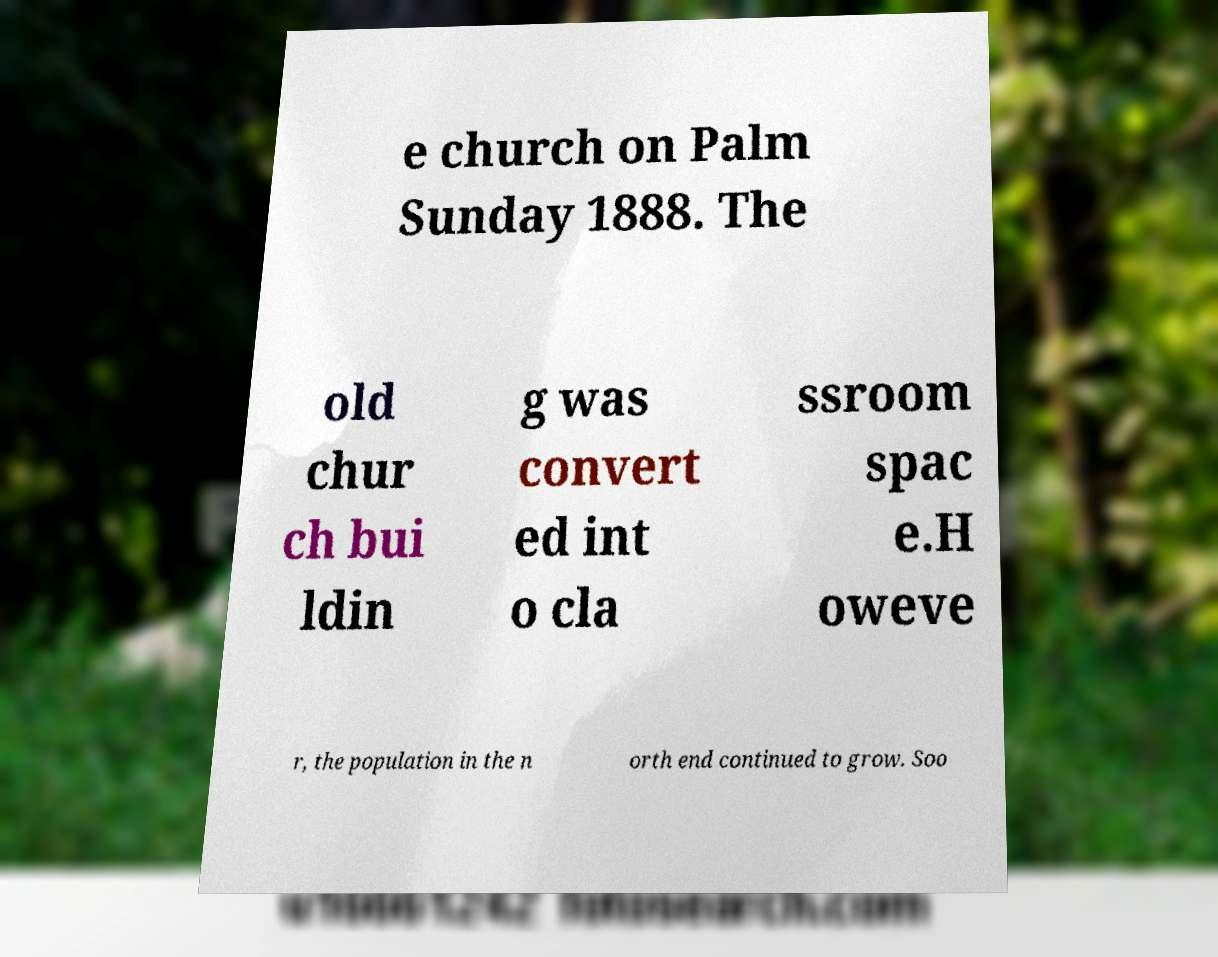There's text embedded in this image that I need extracted. Can you transcribe it verbatim? e church on Palm Sunday 1888. The old chur ch bui ldin g was convert ed int o cla ssroom spac e.H oweve r, the population in the n orth end continued to grow. Soo 